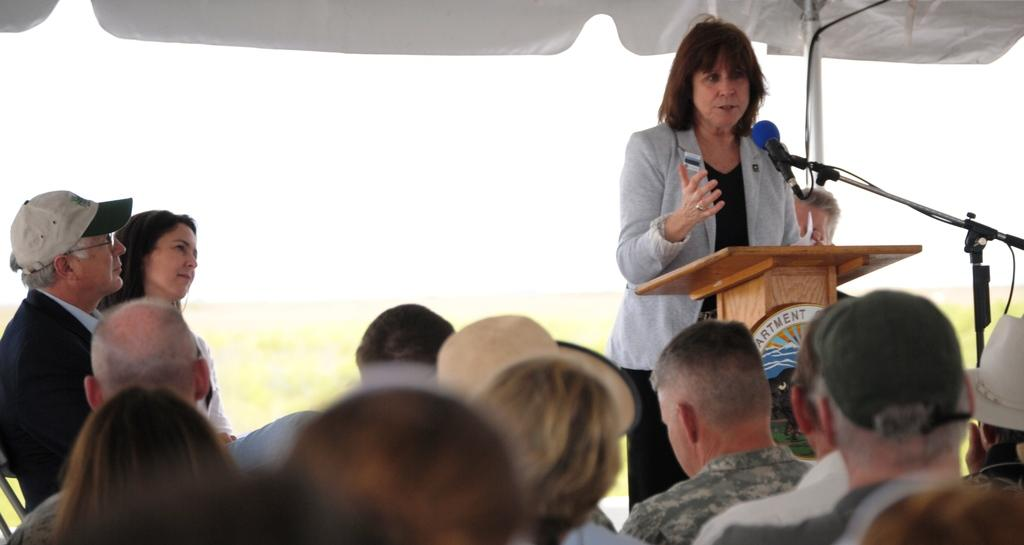What are the people in the image doing? The people in the image are sitting on chairs. What is the woman near the podium doing? The woman is standing near a podium. What object is present for amplifying sound in the image? There is a microphone (mike) in the image. Can you describe the background of the image? The background of the image is blurred. Where is the basin located in the image? There is no basin present in the image. What type of battle is depicted in the image? There is no battle depicted in the image. 